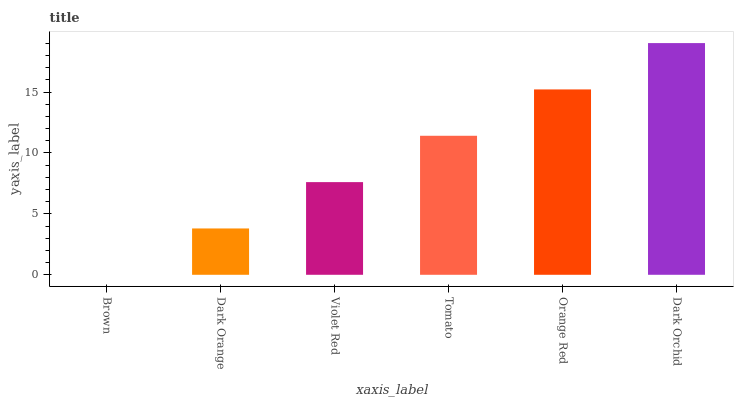Is Brown the minimum?
Answer yes or no. Yes. Is Dark Orchid the maximum?
Answer yes or no. Yes. Is Dark Orange the minimum?
Answer yes or no. No. Is Dark Orange the maximum?
Answer yes or no. No. Is Dark Orange greater than Brown?
Answer yes or no. Yes. Is Brown less than Dark Orange?
Answer yes or no. Yes. Is Brown greater than Dark Orange?
Answer yes or no. No. Is Dark Orange less than Brown?
Answer yes or no. No. Is Tomato the high median?
Answer yes or no. Yes. Is Violet Red the low median?
Answer yes or no. Yes. Is Dark Orange the high median?
Answer yes or no. No. Is Orange Red the low median?
Answer yes or no. No. 